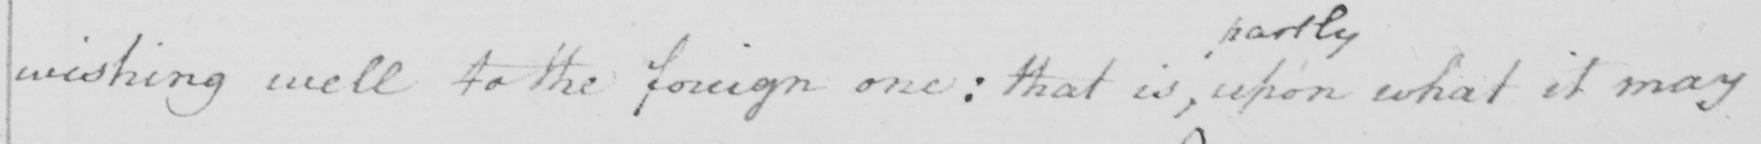Can you read and transcribe this handwriting? wishing well to the foreign one :  that is , upon what it may 